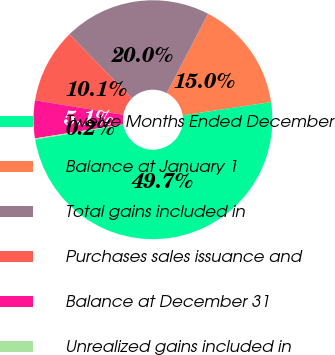Convert chart. <chart><loc_0><loc_0><loc_500><loc_500><pie_chart><fcel>Twelve Months Ended December<fcel>Balance at January 1<fcel>Total gains included in<fcel>Purchases sales issuance and<fcel>Balance at December 31<fcel>Unrealized gains included in<nl><fcel>49.7%<fcel>15.01%<fcel>19.97%<fcel>10.06%<fcel>5.1%<fcel>0.15%<nl></chart> 